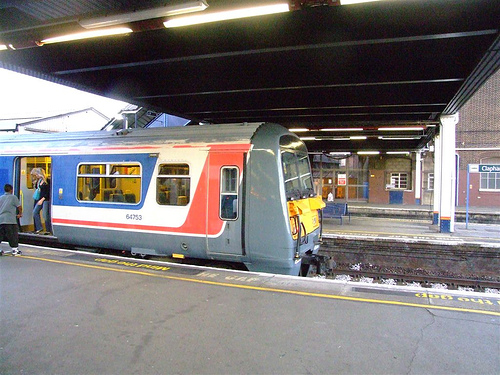What time of day does it seem to be at the train station? Judging by the lighting and shadows in the image, it appears to be daytime, possibly morning or late afternoon. 